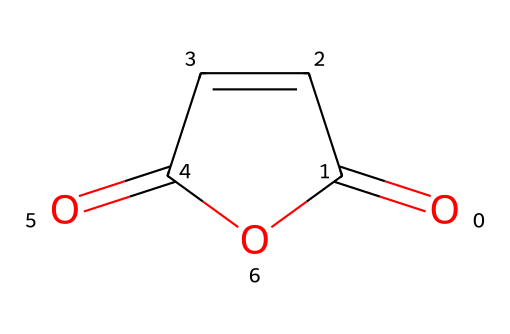What is the name of the chemical represented by this SMILES? The given SMILES corresponds to maleic anhydride, which is recognized by its structure featuring two carbonyl groups adjacent to a cyclic structure.
Answer: maleic anhydride How many carbon atoms are present in the structure? The SMILES indicates that there are four carbon atoms in the cyclic and double-bonded structure of maleic anhydride.
Answer: 4 What type of functional groups are present? The structure shows two carbonyl groups (C=O) and an anhydride functional group. The analysis of the SMILES confirms these functional groups.
Answer: carbonyl and anhydride What is the total number of oxygen atoms in the molecule? By counting the occurrences in the SMILES representation, we see that there are three oxygen atoms in total, which includes the two carbonyl oxygens and one anhydride oxygen.
Answer: 3 Why is maleic anhydride considered an acid anhydride? Maleic anhydride is an acid anhydride because it is derived from the corresponding carboxylic acid (maleic acid) by the loss of water, hence facilitating reactions with nucleophiles.
Answer: derived from maleic acid What is the significance of maleic anhydride in aerospace composites? Maleic anhydride is often used as a key ingredient in polymer formulations for aerospace composites due to its ability to improve adhesion and thermal stability.
Answer: adhesion and thermal stability 